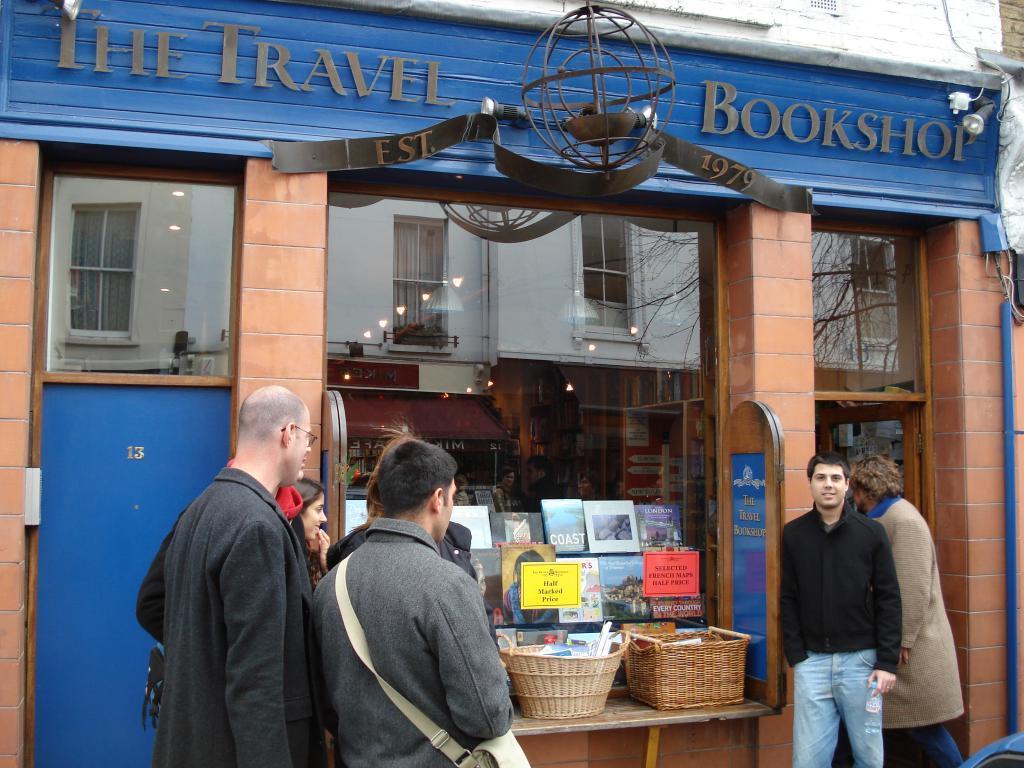In one or two sentences, can you explain what this image depicts? There is a group of persons standing on the left side of this image and there are two persons are standing on the right side of this image. There is a shop where we can see some baskets and books in the middle of this image. There is a text written on this building at the top of this image. 